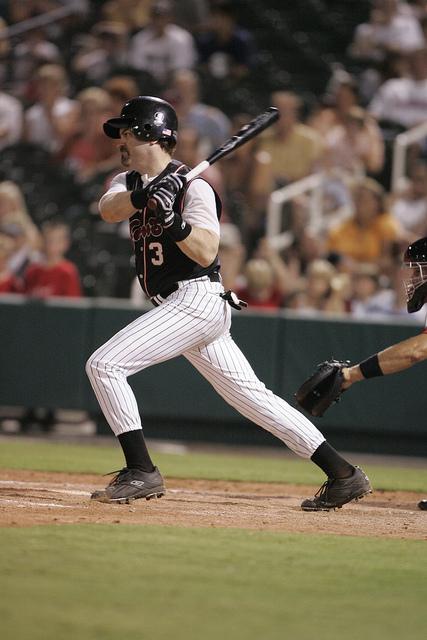Is this really America's favorite pastime?
Keep it brief. Yes. What color is his socks?
Be succinct. Black. What sport is the man playing?
Answer briefly. Baseball. 